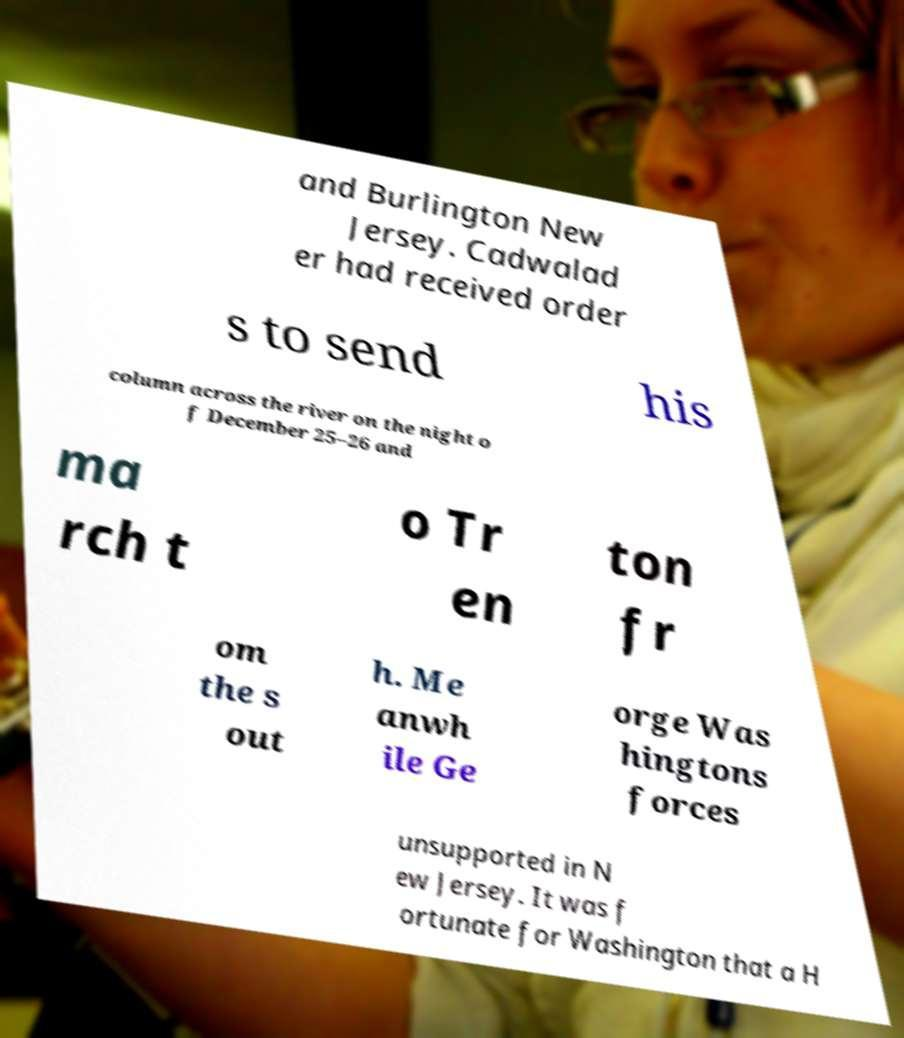Please read and relay the text visible in this image. What does it say? and Burlington New Jersey. Cadwalad er had received order s to send his column across the river on the night o f December 25–26 and ma rch t o Tr en ton fr om the s out h. Me anwh ile Ge orge Was hingtons forces unsupported in N ew Jersey. It was f ortunate for Washington that a H 